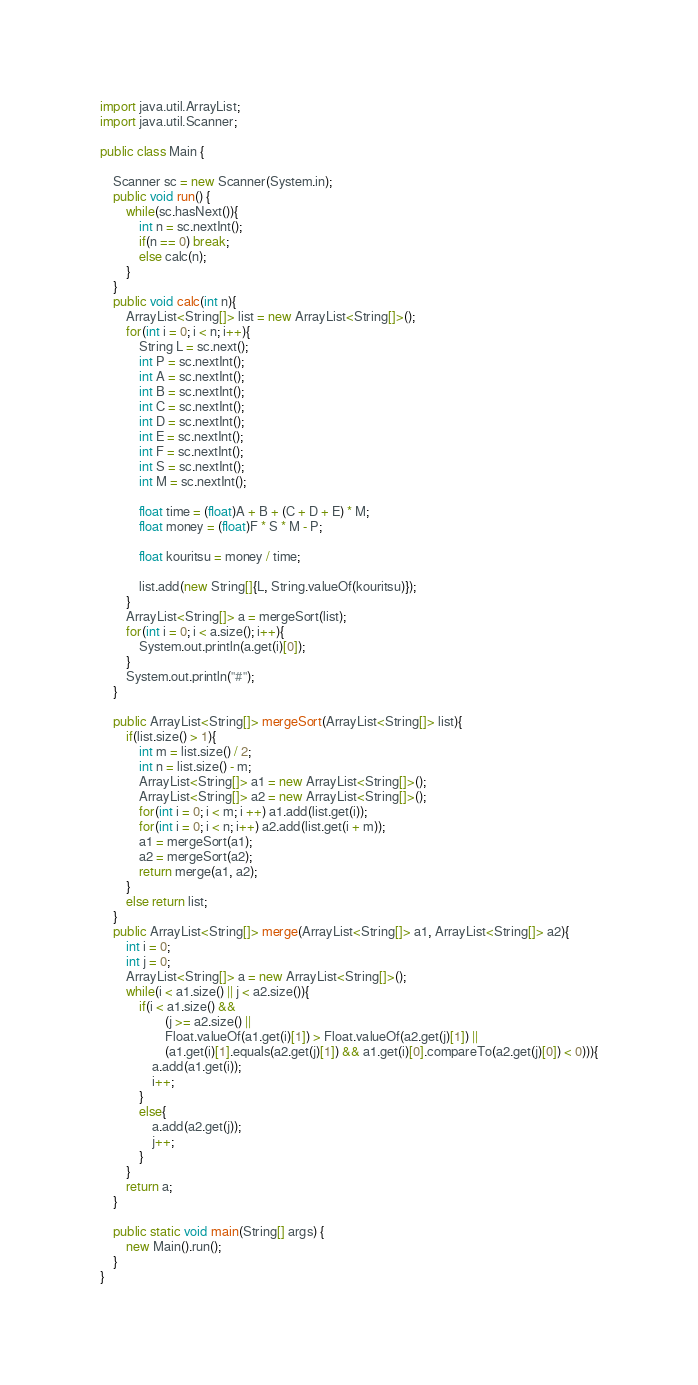Convert code to text. <code><loc_0><loc_0><loc_500><loc_500><_Java_>import java.util.ArrayList;
import java.util.Scanner;

public class Main {

	Scanner sc = new Scanner(System.in);
	public void run() {
		while(sc.hasNext()){
			int n = sc.nextInt();
			if(n == 0) break;
			else calc(n);
		}
	}
	public void calc(int n){
		ArrayList<String[]> list = new ArrayList<String[]>();
		for(int i = 0; i < n; i++){
			String L = sc.next();
			int P = sc.nextInt();
			int A = sc.nextInt();
			int B = sc.nextInt();
			int C = sc.nextInt();
			int D = sc.nextInt();
			int E = sc.nextInt();
			int F = sc.nextInt();
			int S = sc.nextInt();
			int M = sc.nextInt();
			
			float time = (float)A + B + (C + D + E) * M;
			float money = (float)F * S * M - P;
			
			float kouritsu = money / time;
			
			list.add(new String[]{L, String.valueOf(kouritsu)});
		}
		ArrayList<String[]> a = mergeSort(list);
		for(int i = 0; i < a.size(); i++){
			System.out.println(a.get(i)[0]);
		}
		System.out.println("#");
	}

	public ArrayList<String[]> mergeSort(ArrayList<String[]> list){
		if(list.size() > 1){
			int m = list.size() / 2;
			int n = list.size() - m;
			ArrayList<String[]> a1 = new ArrayList<String[]>();
			ArrayList<String[]> a2 = new ArrayList<String[]>();
			for(int i = 0; i < m; i ++) a1.add(list.get(i));
			for(int i = 0; i < n; i++) a2.add(list.get(i + m));
			a1 = mergeSort(a1);
			a2 = mergeSort(a2);
			return merge(a1, a2);
		}
		else return list;
	}
	public ArrayList<String[]> merge(ArrayList<String[]> a1, ArrayList<String[]> a2){
		int i = 0;
		int j = 0;
		ArrayList<String[]> a = new ArrayList<String[]>();
		while(i < a1.size() || j < a2.size()){
			if(i < a1.size() && 
					(j >= a2.size() || 
					Float.valueOf(a1.get(i)[1]) > Float.valueOf(a2.get(j)[1]) || 
					(a1.get(i)[1].equals(a2.get(j)[1]) && a1.get(i)[0].compareTo(a2.get(j)[0]) < 0))){
				a.add(a1.get(i));
				i++;
			}
			else{
				a.add(a2.get(j));
				j++;
			}
		}
		return a;
	}
	
	public static void main(String[] args) {
		new Main().run();
	}
}</code> 